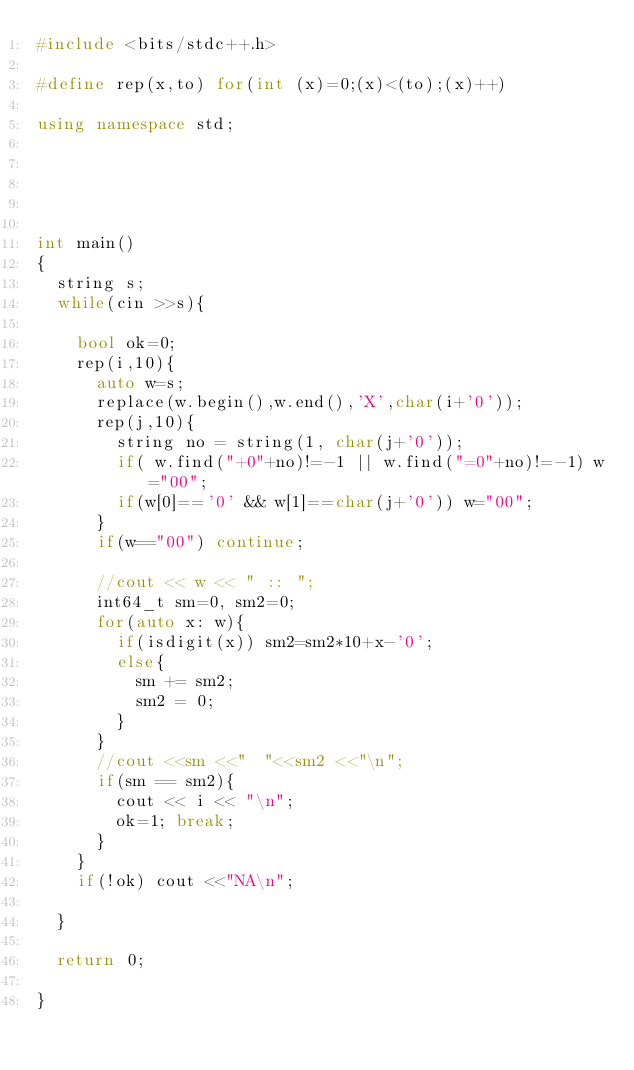Convert code to text. <code><loc_0><loc_0><loc_500><loc_500><_C++_>#include <bits/stdc++.h>

#define rep(x,to) for(int (x)=0;(x)<(to);(x)++)

using namespace std;





int main()
{
	string s;
	while(cin >>s){
	
		bool ok=0;
		rep(i,10){
			auto w=s;
			replace(w.begin(),w.end(),'X',char(i+'0'));
			rep(j,10){
				string no = string(1, char(j+'0'));
				if( w.find("+0"+no)!=-1 || w.find("=0"+no)!=-1) w="00";
				if(w[0]=='0' && w[1]==char(j+'0')) w="00";
			}
			if(w=="00") continue;
			
			//cout << w << " :: ";
			int64_t sm=0, sm2=0;
			for(auto x: w){
				if(isdigit(x)) sm2=sm2*10+x-'0';
				else{
					sm += sm2;
					sm2 = 0;
				}
			}
			//cout <<sm <<"  "<<sm2 <<"\n";
			if(sm == sm2){
				cout << i << "\n";
				ok=1; break;
			}
		}
		if(!ok) cout <<"NA\n";
	
	}
	
	return 0;

}</code> 